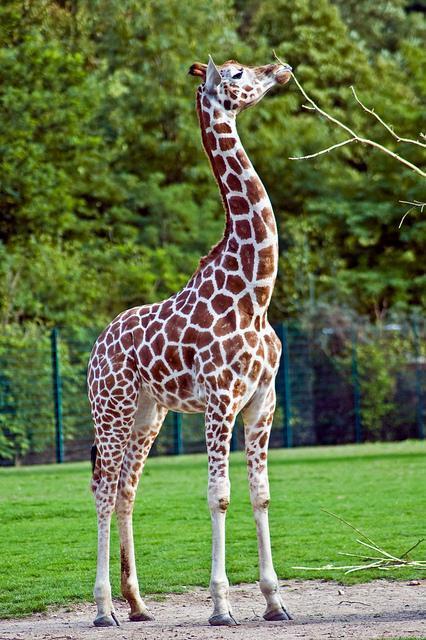How many legs does the giraffe have?
Give a very brief answer. 4. 